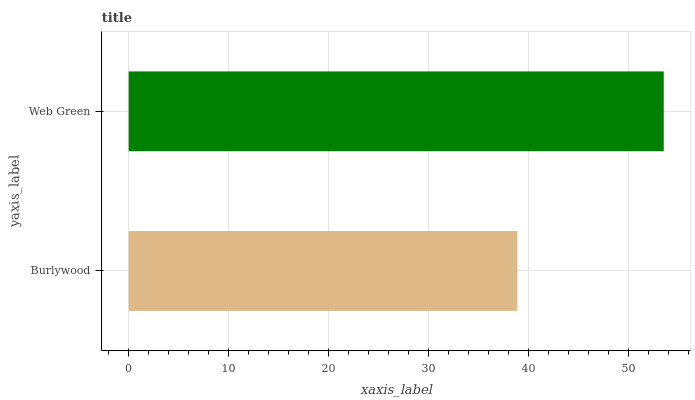Is Burlywood the minimum?
Answer yes or no. Yes. Is Web Green the maximum?
Answer yes or no. Yes. Is Web Green the minimum?
Answer yes or no. No. Is Web Green greater than Burlywood?
Answer yes or no. Yes. Is Burlywood less than Web Green?
Answer yes or no. Yes. Is Burlywood greater than Web Green?
Answer yes or no. No. Is Web Green less than Burlywood?
Answer yes or no. No. Is Web Green the high median?
Answer yes or no. Yes. Is Burlywood the low median?
Answer yes or no. Yes. Is Burlywood the high median?
Answer yes or no. No. Is Web Green the low median?
Answer yes or no. No. 